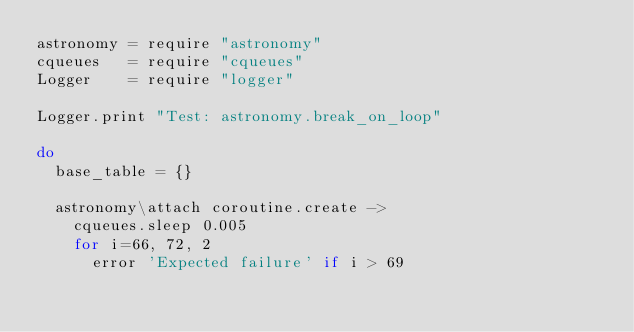<code> <loc_0><loc_0><loc_500><loc_500><_MoonScript_>astronomy = require "astronomy"
cqueues   = require "cqueues"
Logger    = require "logger"

Logger.print "Test: astronomy.break_on_loop"

do
	base_table = {}

	astronomy\attach coroutine.create ->
		cqueues.sleep 0.005
		for i=66, 72, 2
			error 'Expected failure' if i > 69</code> 